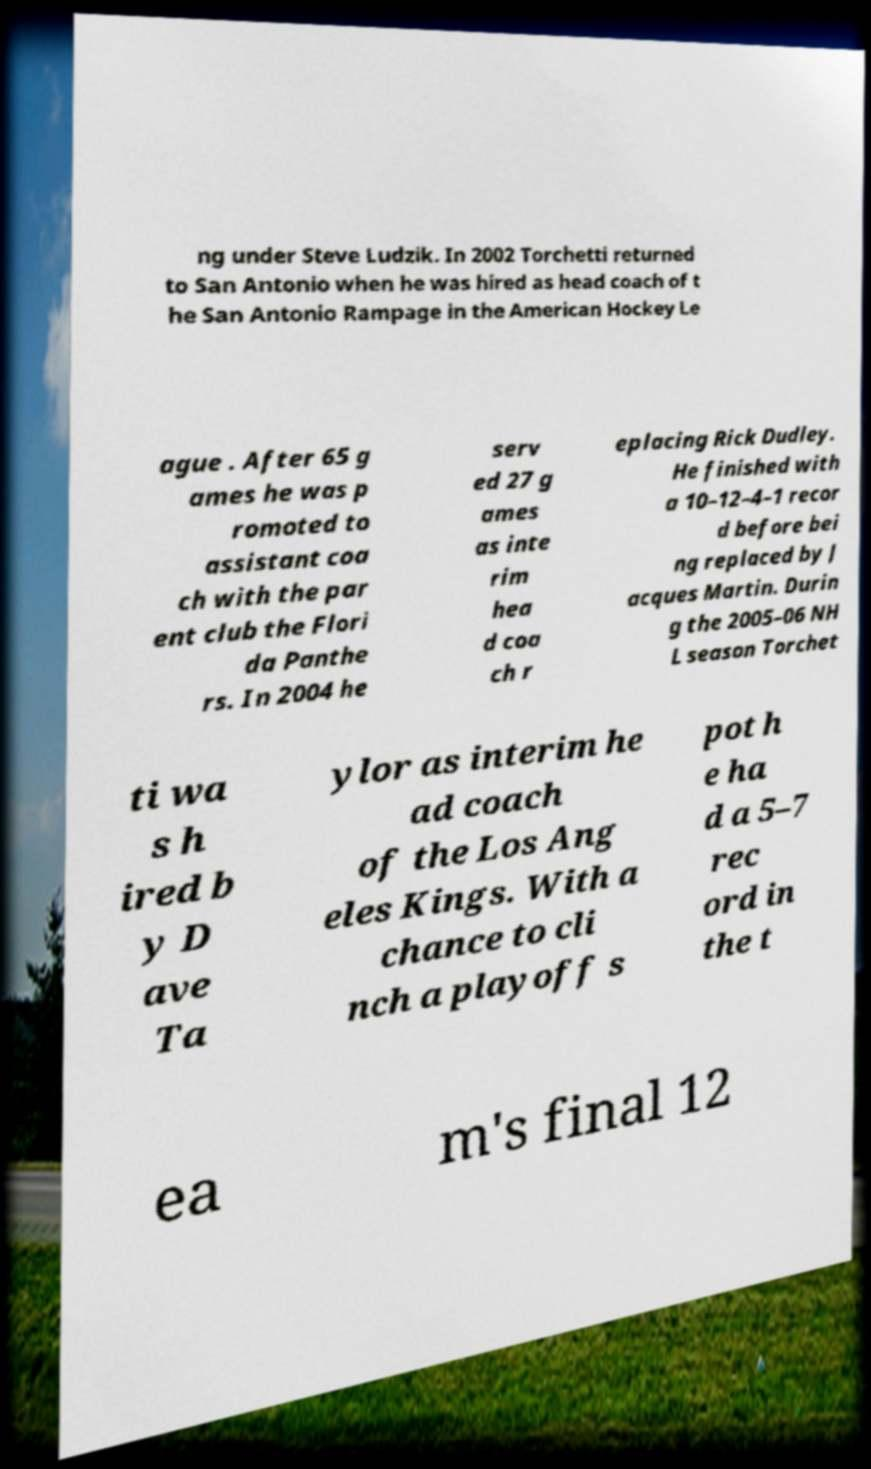Could you assist in decoding the text presented in this image and type it out clearly? ng under Steve Ludzik. In 2002 Torchetti returned to San Antonio when he was hired as head coach of t he San Antonio Rampage in the American Hockey Le ague . After 65 g ames he was p romoted to assistant coa ch with the par ent club the Flori da Panthe rs. In 2004 he serv ed 27 g ames as inte rim hea d coa ch r eplacing Rick Dudley. He finished with a 10–12–4–1 recor d before bei ng replaced by J acques Martin. Durin g the 2005–06 NH L season Torchet ti wa s h ired b y D ave Ta ylor as interim he ad coach of the Los Ang eles Kings. With a chance to cli nch a playoff s pot h e ha d a 5–7 rec ord in the t ea m's final 12 